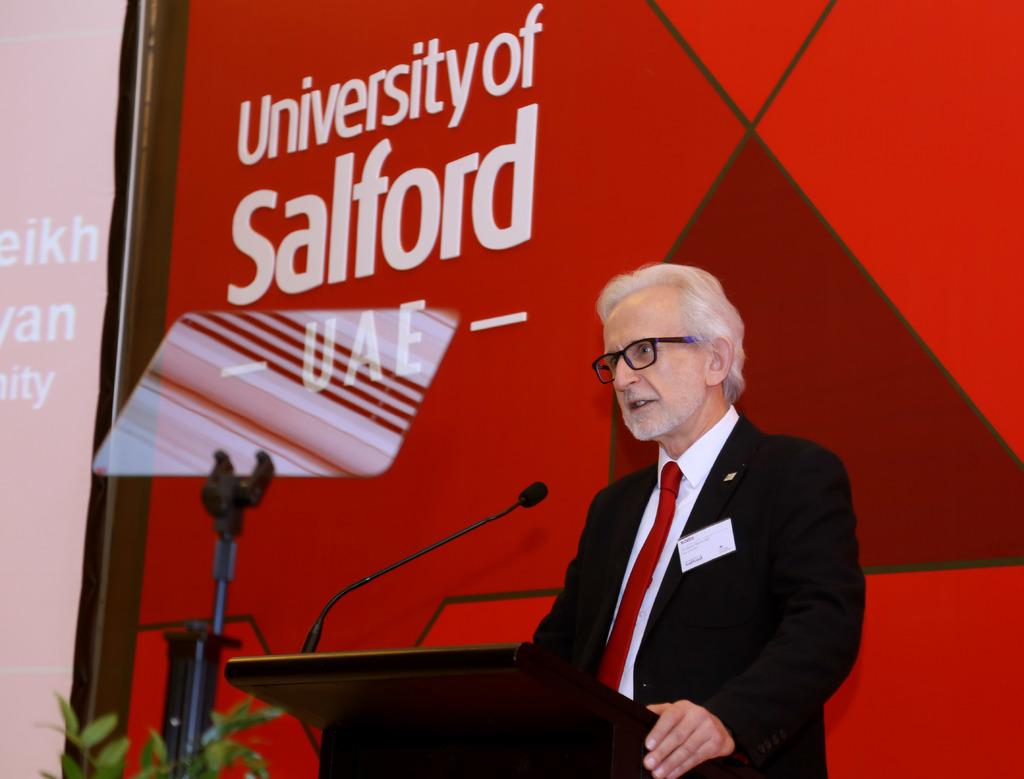Who is the main subject in the image? There is a man in the image. What is the man standing in front of? The man is standing in front of a podium with a mic. What can be seen in the background of the image? There is a screen, a plant, and a stand in the background of the image. What is the color of the wall in the background? The wall in the background is red. What is written on the red wall? There is something written on the red wall. Can you tell me how many squirrels are participating in the battle depicted on the red wall? There is no battle or squirrels depicted on the red wall; it only has writing on it. 